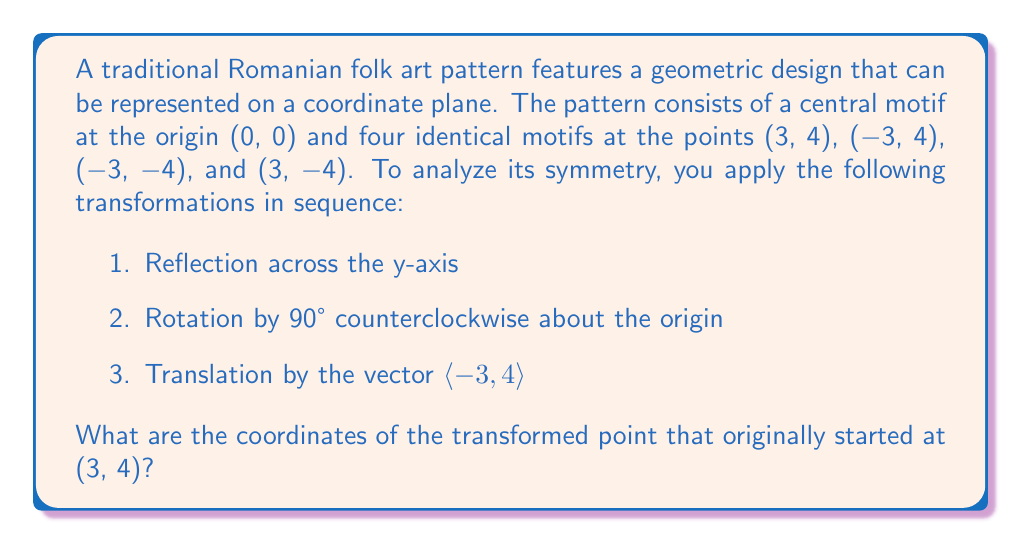Could you help me with this problem? Let's approach this step-by-step:

1. Reflection across the y-axis:
   The point (3, 4) becomes (-3, 4)
   $$(x, y) \rightarrow (-x, y)$$

2. Rotation by 90° counterclockwise about the origin:
   To rotate (-3, 4) by 90° counterclockwise, we use the rotation matrix:
   $$\begin{pmatrix} \cos 90° & -\sin 90° \\ \sin 90° & \cos 90° \end{pmatrix} = \begin{pmatrix} 0 & -1 \\ 1 & 0 \end{pmatrix}$$
   
   Applying this to (-3, 4):
   $$\begin{pmatrix} 0 & -1 \\ 1 & 0 \end{pmatrix} \begin{pmatrix} -3 \\ 4 \end{pmatrix} = \begin{pmatrix} -4 \\ -3 \end{pmatrix}$$
   
   So after rotation, the point is at (-4, -3)

3. Translation by the vector $\langle -3, 4 \rangle$:
   We add this vector to our current coordinates:
   $$(-4, -3) + (-3, 4) = (-7, 1)$$

Therefore, after all transformations, the point that started at (3, 4) ends up at (-7, 1).

This sequence of transformations preserves the symmetry of the original pattern while repositioning it, which is common in Romanian folk art where patterns are often repeated and transformed to create larger, more complex designs.
Answer: (-7, 1) 